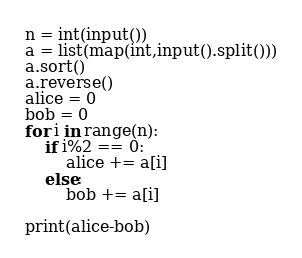Convert code to text. <code><loc_0><loc_0><loc_500><loc_500><_Python_>n = int(input())
a = list(map(int,input().split()))
a.sort()
a.reverse()
alice = 0
bob = 0
for i in range(n):
	if i%2 == 0:
		alice += a[i]
	else:
		bob += a[i]

print(alice-bob)</code> 